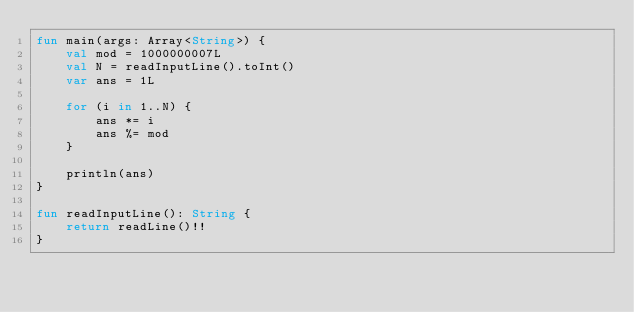Convert code to text. <code><loc_0><loc_0><loc_500><loc_500><_Kotlin_>fun main(args: Array<String>) {
    val mod = 1000000007L
    val N = readInputLine().toInt()
    var ans = 1L
    
    for (i in 1..N) {
        ans *= i
        ans %= mod
    }
    
    println(ans)
}

fun readInputLine(): String {
    return readLine()!!
}
</code> 